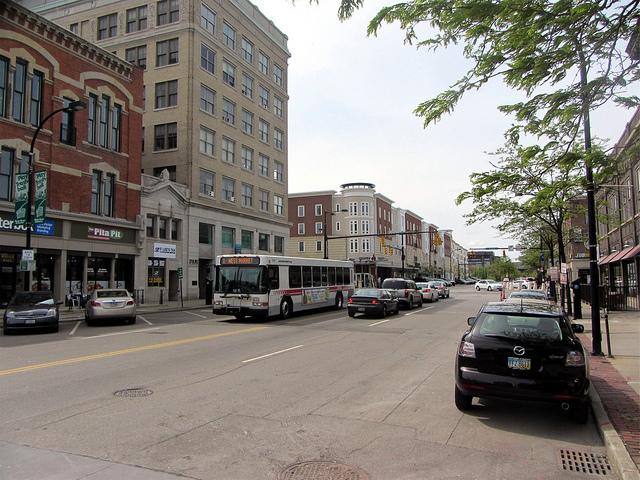Is there a horse carriage on the street?
Give a very brief answer. No. What would the black car in the foreground do to get to the green building?
Give a very brief answer. Drive. What is their near to car?
Concise answer only. Tree. Is this India?
Answer briefly. No. What color vehicle is closest to the screen?
Write a very short answer. Black. What kind of trees are in this scene?
Be succinct. Elm. Are there any cars on this road?
Concise answer only. Yes. Where is the street located in?
Quick response, please. London. What type of vehicle is parked here?
Keep it brief. Car. Has it snowed there?
Give a very brief answer. No. How many buses do you see?
Keep it brief. 1. Is this a clean city?
Concise answer only. Yes. Why is the building red?
Short answer required. Made of bricks. Is this a one-way?
Give a very brief answer. No. What city does this look like?
Answer briefly. Chicago. Is the same building in both photo's?
Keep it brief. No. Does this look like the olden days?
Be succinct. No. How many levels is the bus?
Be succinct. 1. What is the color of the car behind?
Keep it brief. Black. How many cars are parked?
Give a very brief answer. 4. Does this road need to be paved?
Concise answer only. No. How many cars are in this picture?
Be succinct. 10. IS the a two story bus?
Short answer required. No. Is this a rural scene?
Short answer required. No. What is the number of this platform?
Answer briefly. Unknown. What is behind the white SUV?
Give a very brief answer. Car. Are there people walking on the road?
Concise answer only. No. What is the name on the building?
Answer briefly. Pita pit. Is this a one way street?
Keep it brief. No. 